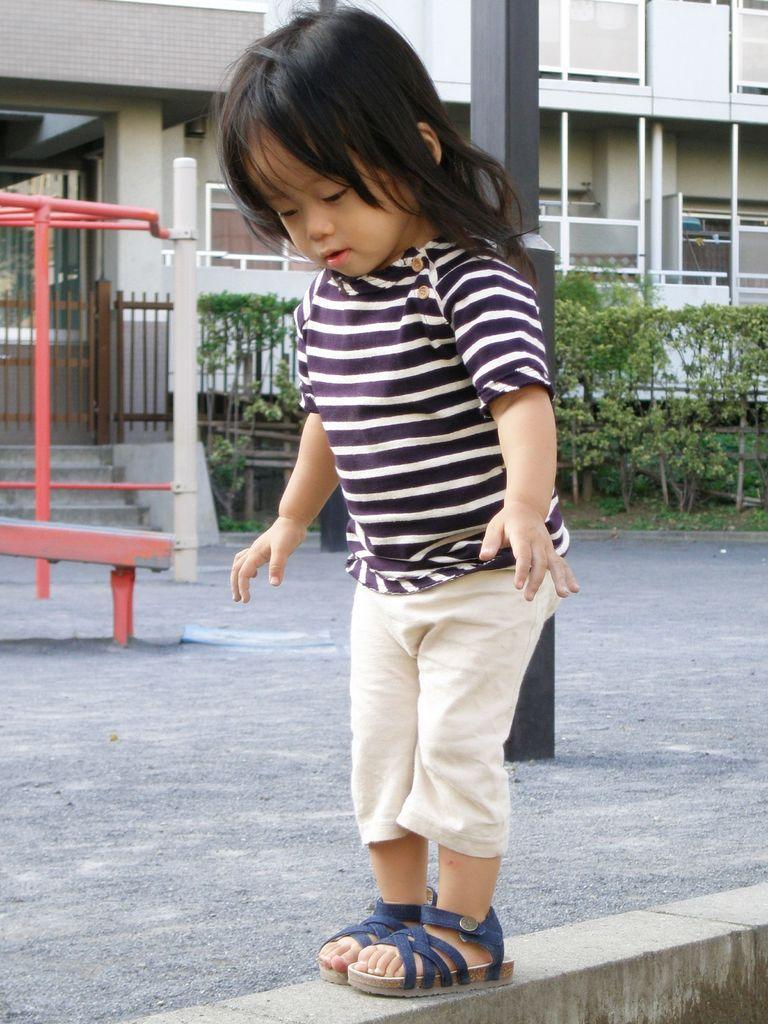Could you give a brief overview of what you see in this image? In this picture we can see a girl standing and looking downwards. In the background we can see a building, fence, plants and the grass. On the left side we can see rods in white and pink color on the road. We can see a black pole behind a girl. 